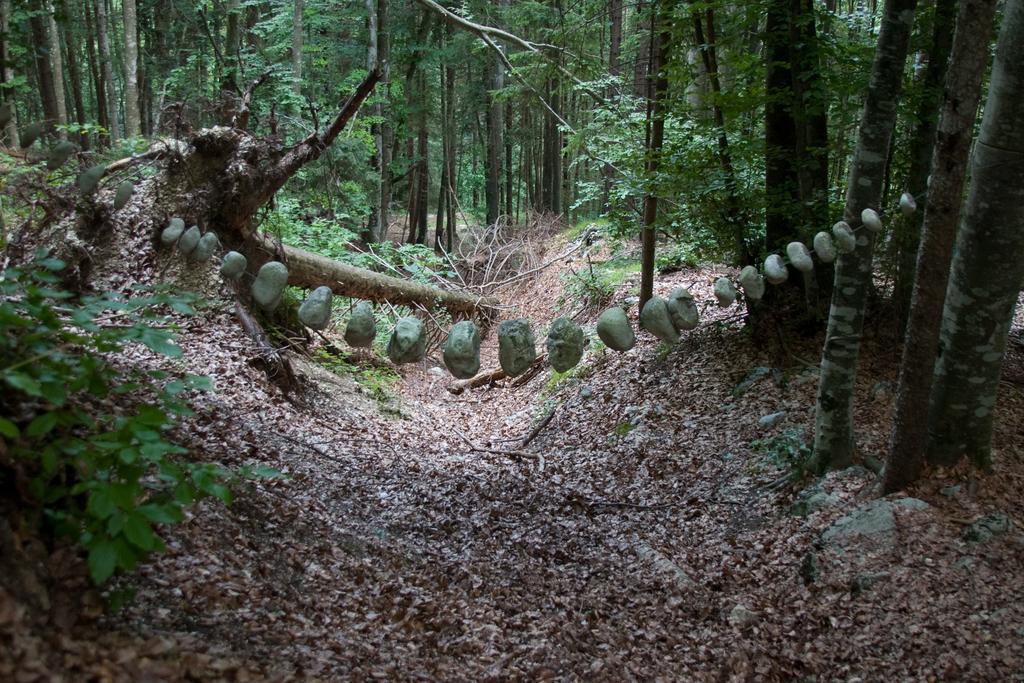Please provide a concise description of this image. In this image I can see few objects and these objects looks like stones. In the background I can see few trees in green color. 